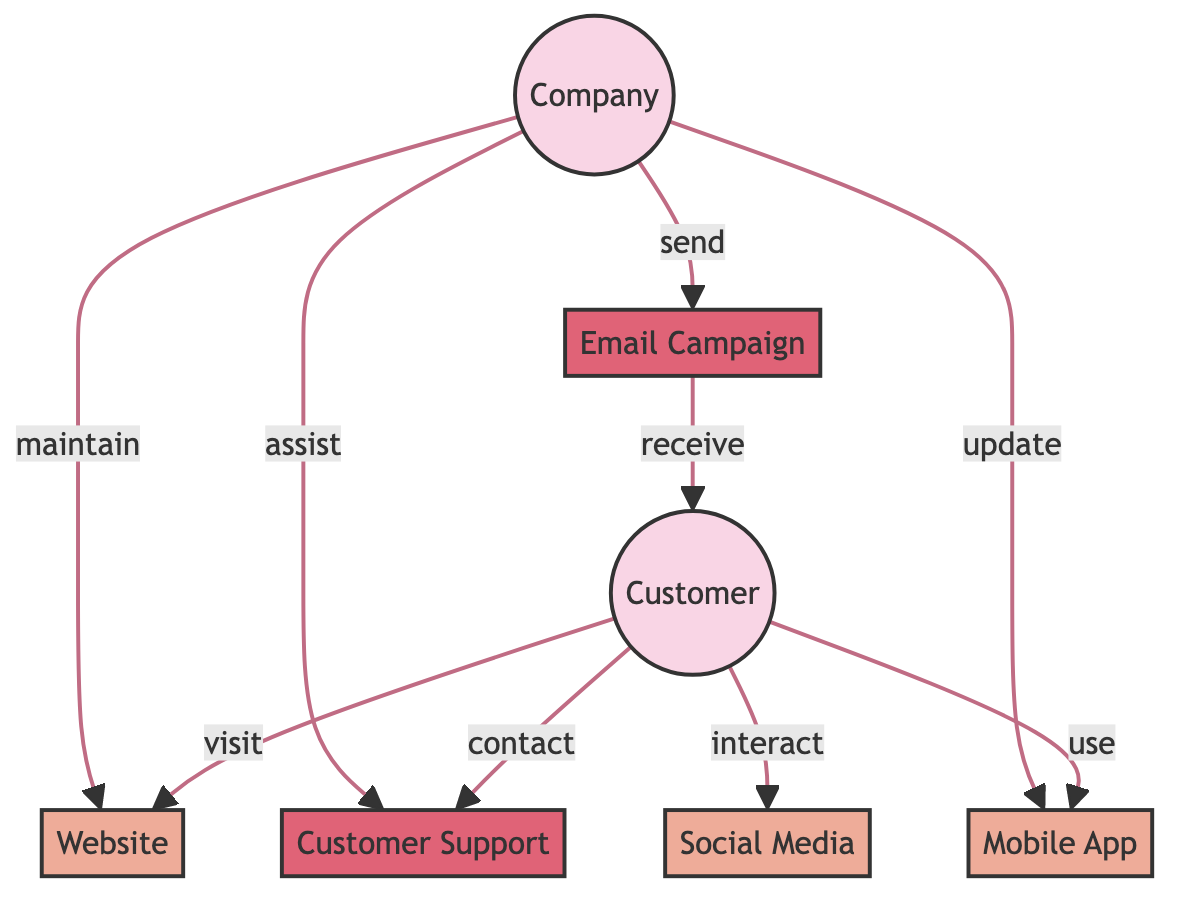What is the total number of nodes in the diagram? There are 7 nodes in total: Customer, Company, Website, Mobile App, Email Campaign, Customer Support, and Social Media.
Answer: 7 How many touchpoints are represented in the diagram? The touchpoints represented are Website, Mobile App, and Social Media, which totals 3.
Answer: 3 What type of interaction does the Customer have with the Email Campaign? The Customer receives the Email Campaign, indicating a communication interaction.
Answer: receive What type of entity is the Company? The Company is classified as a provider in the diagram.
Answer: Provider Which entity interacts with Customer Support and how? The Customer contacts Customer Support. The interaction is described as a direct contact.
Answer: contact What are the attributes associated with the Mobile App touchpoint? The Mobile App has the following attributes: App Usage, Push Notifications, and In-App Purchases.
Answer: App Usage, Push Notifications, In-App Purchases Which two nodes participate in sending and receiving the Email Campaign? The Company sends the Email Campaign, which is then received by the Customer. Therefore, the two nodes are Company and Customer.
Answer: Company, Customer What is the interaction type of Website? The Website is classified as a digital touchpoint with a specific interaction type.
Answer: Digital How does the Company maintain the Website? The Company maintains the Website by connecting to it as indicated by the interaction "maintain."
Answer: maintain 